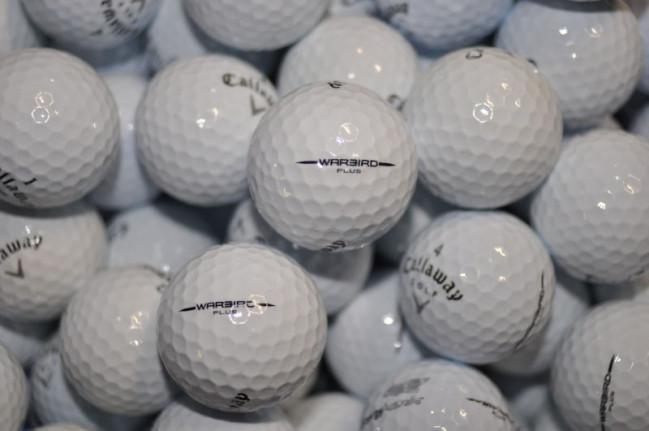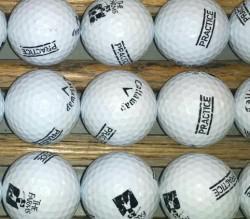The first image is the image on the left, the second image is the image on the right. For the images shown, is this caption "The golfballs in the image on the right are not in shadow." true? Answer yes or no. Yes. The first image is the image on the left, the second image is the image on the right. Given the left and right images, does the statement "Golf balls in the left image look noticeably darker and grayer than those in the right image." hold true? Answer yes or no. Yes. 